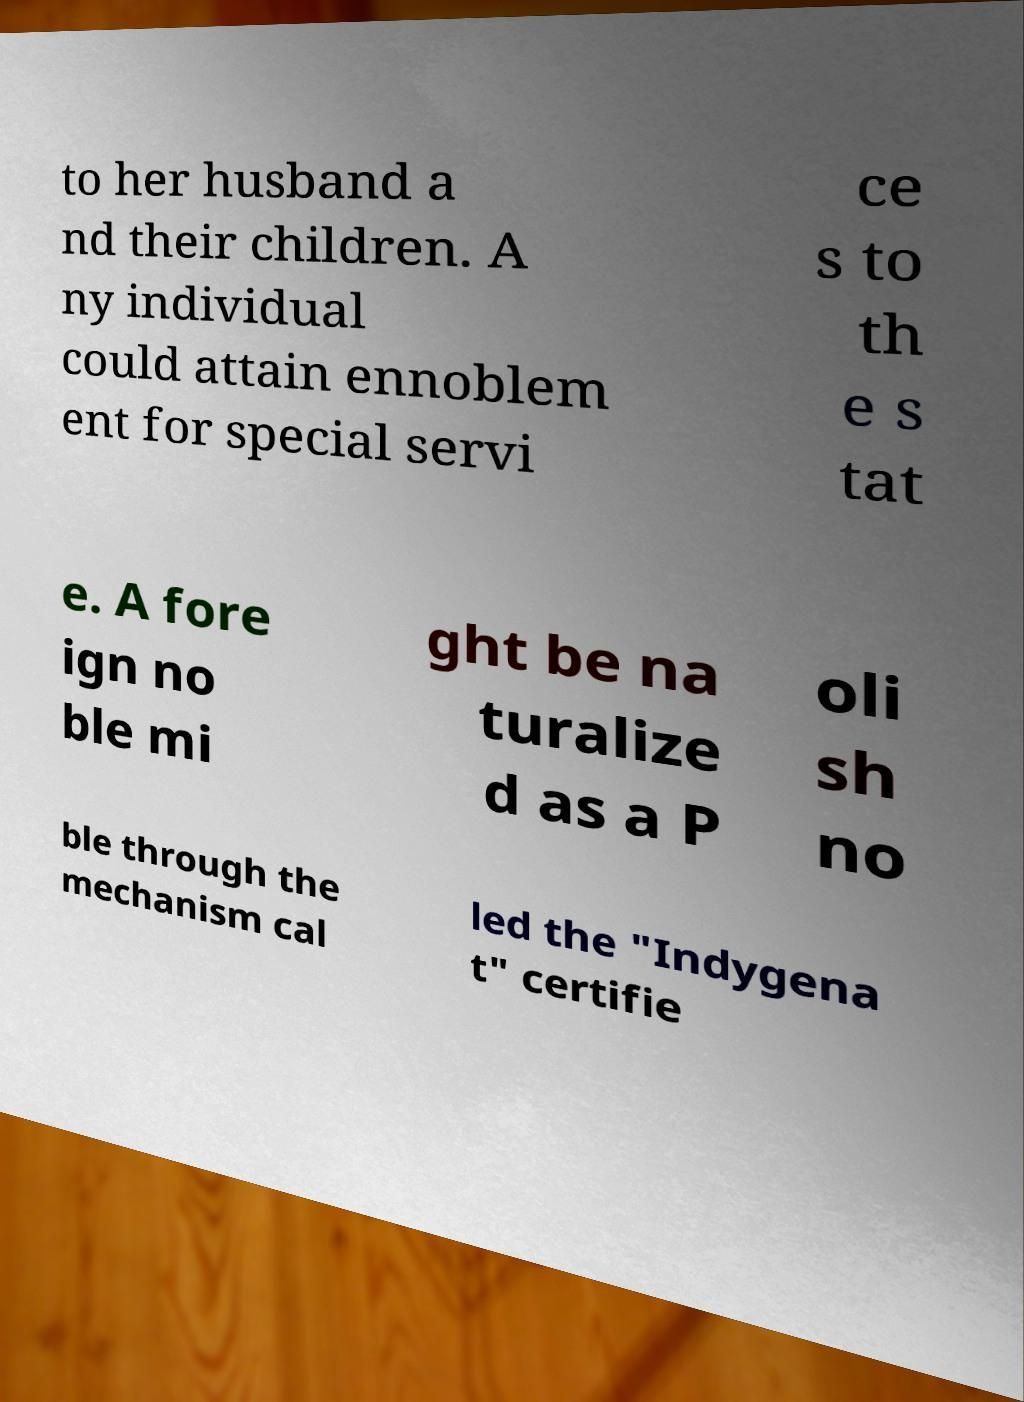There's text embedded in this image that I need extracted. Can you transcribe it verbatim? to her husband a nd their children. A ny individual could attain ennoblem ent for special servi ce s to th e s tat e. A fore ign no ble mi ght be na turalize d as a P oli sh no ble through the mechanism cal led the "Indygena t" certifie 